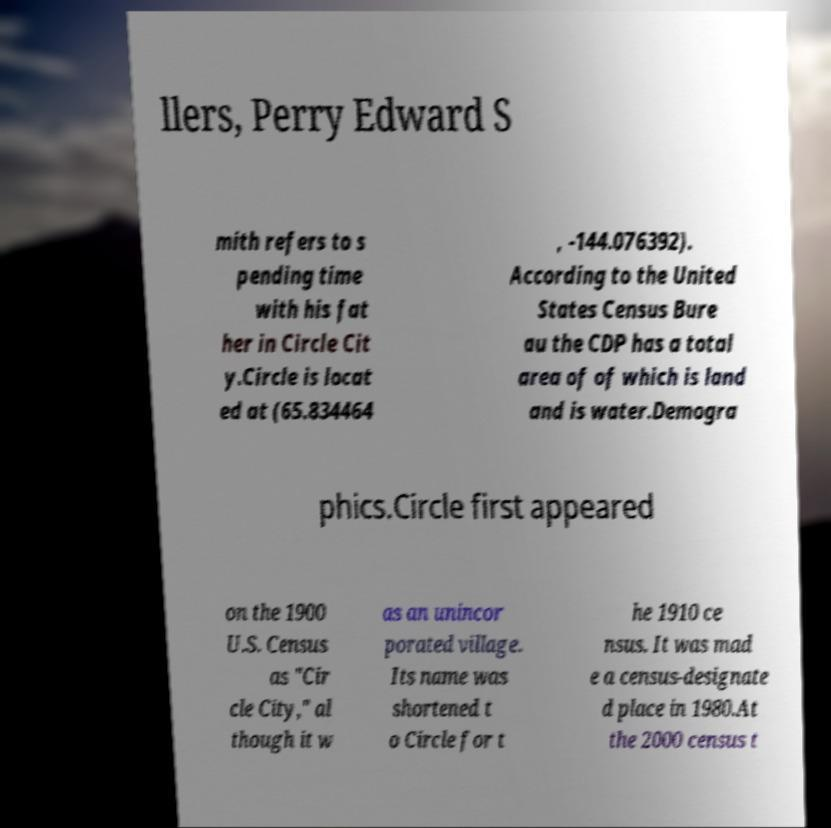For documentation purposes, I need the text within this image transcribed. Could you provide that? llers, Perry Edward S mith refers to s pending time with his fat her in Circle Cit y.Circle is locat ed at (65.834464 , -144.076392). According to the United States Census Bure au the CDP has a total area of of which is land and is water.Demogra phics.Circle first appeared on the 1900 U.S. Census as "Cir cle City," al though it w as an unincor porated village. Its name was shortened t o Circle for t he 1910 ce nsus. It was mad e a census-designate d place in 1980.At the 2000 census t 